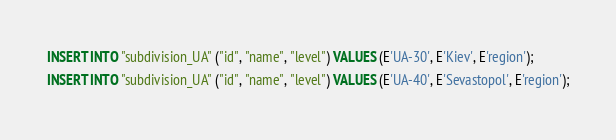<code> <loc_0><loc_0><loc_500><loc_500><_SQL_>INSERT INTO "subdivision_UA" ("id", "name", "level") VALUES (E'UA-30', E'Kiev', E'region');
INSERT INTO "subdivision_UA" ("id", "name", "level") VALUES (E'UA-40', E'Sevastopol', E'region');
</code> 